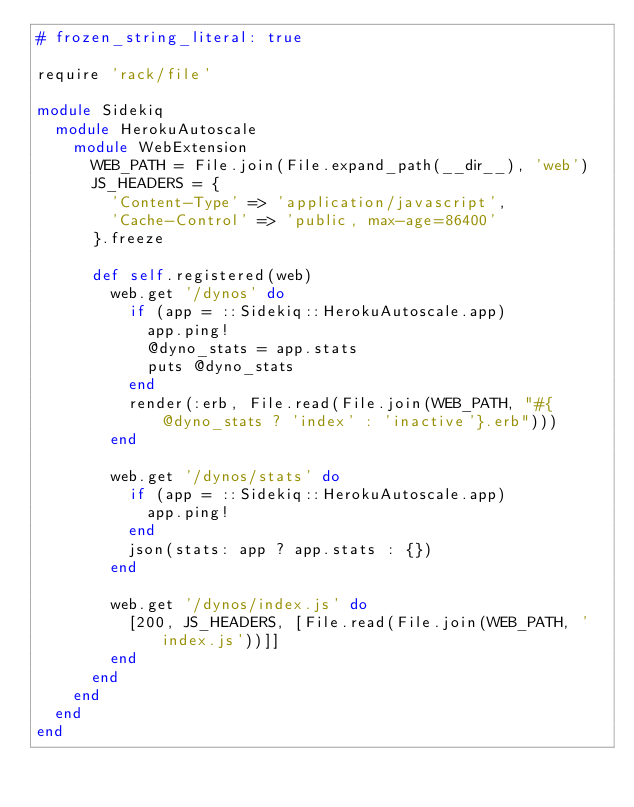Convert code to text. <code><loc_0><loc_0><loc_500><loc_500><_Ruby_># frozen_string_literal: true

require 'rack/file'

module Sidekiq
  module HerokuAutoscale
    module WebExtension
      WEB_PATH = File.join(File.expand_path(__dir__), 'web')
      JS_HEADERS = {
        'Content-Type' => 'application/javascript',
        'Cache-Control' => 'public, max-age=86400'
      }.freeze

      def self.registered(web)
        web.get '/dynos' do
          if (app = ::Sidekiq::HerokuAutoscale.app)
            app.ping!
            @dyno_stats = app.stats
            puts @dyno_stats
          end
          render(:erb, File.read(File.join(WEB_PATH, "#{@dyno_stats ? 'index' : 'inactive'}.erb")))
        end

        web.get '/dynos/stats' do
          if (app = ::Sidekiq::HerokuAutoscale.app)
            app.ping!
          end
          json(stats: app ? app.stats : {})
        end

        web.get '/dynos/index.js' do
          [200, JS_HEADERS, [File.read(File.join(WEB_PATH, 'index.js'))]]
        end
      end
    end
  end
end
</code> 